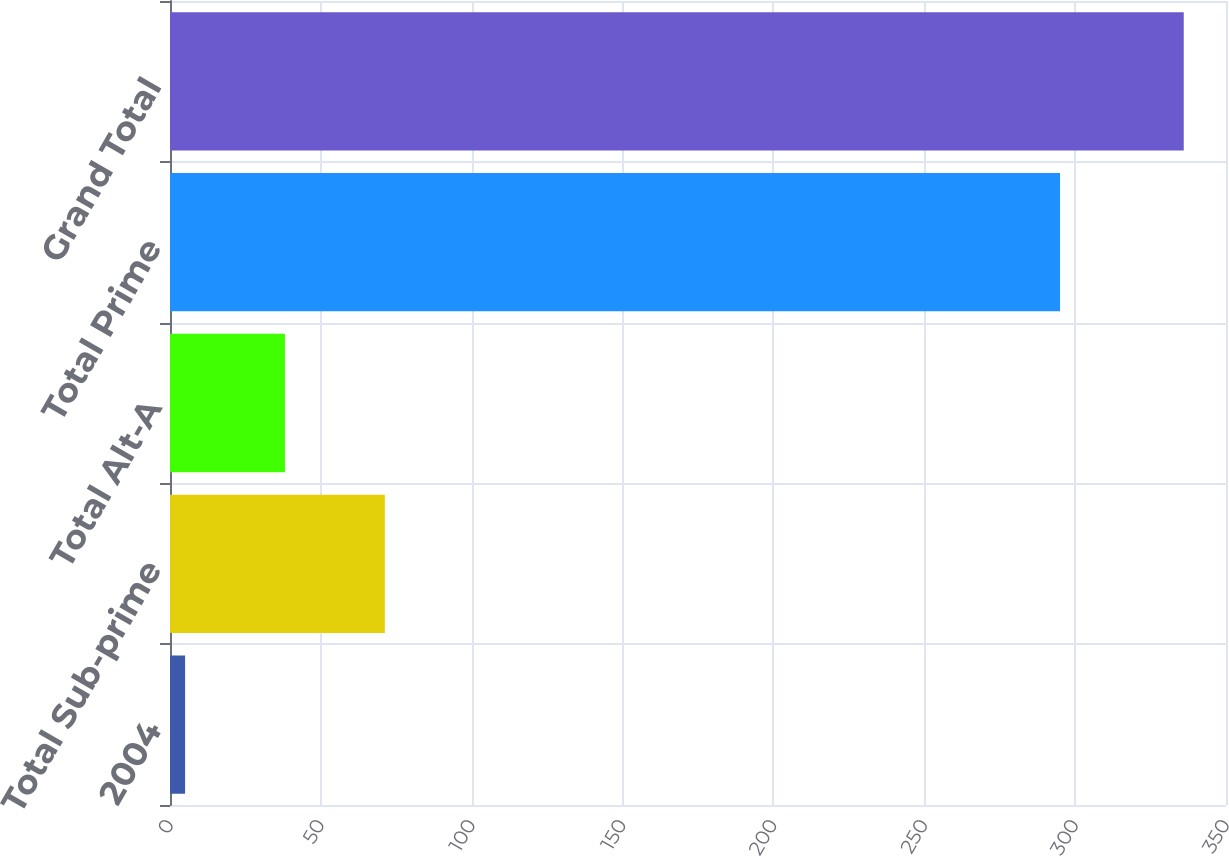Convert chart. <chart><loc_0><loc_0><loc_500><loc_500><bar_chart><fcel>2004<fcel>Total Sub-prime<fcel>Total Alt-A<fcel>Total Prime<fcel>Grand Total<nl><fcel>5<fcel>71.2<fcel>38.1<fcel>295<fcel>336<nl></chart> 